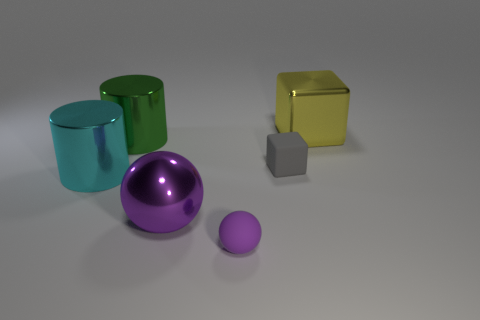How many objects are either tiny gray cubes or large cyan shiny things?
Provide a succinct answer. 2. There is a cylinder in front of the large cylinder that is to the right of the cyan cylinder; what is its material?
Offer a terse response. Metal. Is there another green cylinder that has the same material as the green cylinder?
Give a very brief answer. No. The object behind the big shiny cylinder that is behind the shiny cylinder that is in front of the tiny gray cube is what shape?
Your answer should be compact. Cube. What material is the large green thing?
Provide a short and direct response. Metal. The block that is made of the same material as the small ball is what color?
Your answer should be compact. Gray. Is there a big cyan metallic object that is behind the cube that is on the left side of the yellow thing?
Your response must be concise. No. How many other objects are the same shape as the gray thing?
Provide a succinct answer. 1. There is a tiny rubber object in front of the tiny gray object; is its shape the same as the big shiny thing that is right of the large metallic sphere?
Your response must be concise. No. There is a cube in front of the cube that is behind the big green shiny thing; how many gray things are in front of it?
Offer a very short reply. 0. 